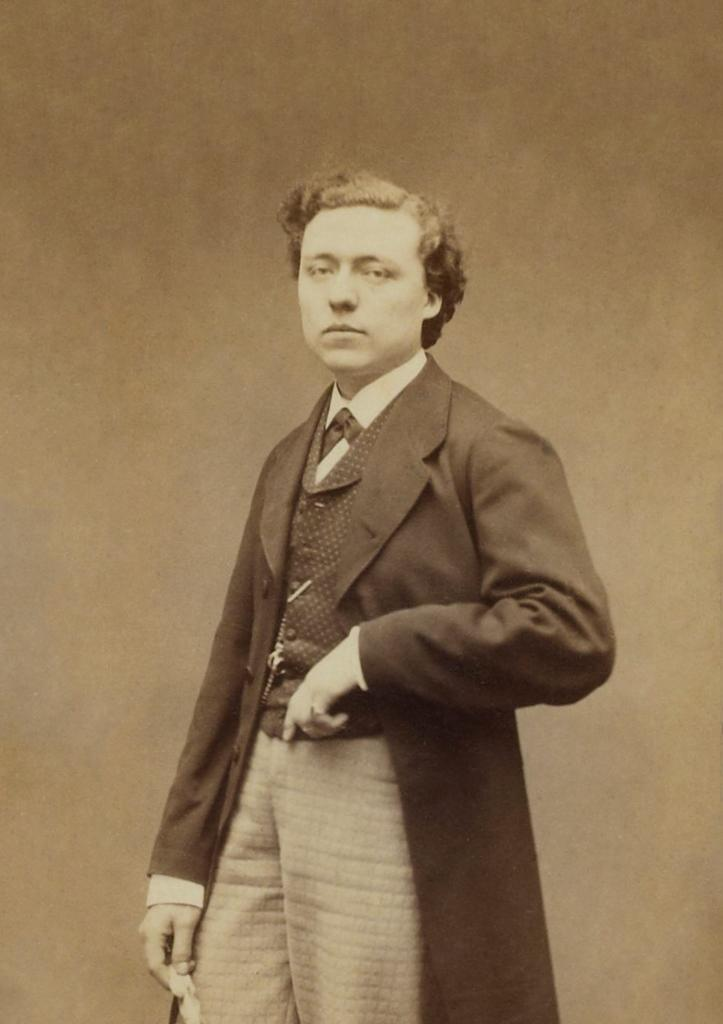What is the main subject of the image? There is a person standing in the front of the image. Can you describe the person's attire? The person is wearing a suit. What is the color scheme of the image? The image is in black and white. What type of copper quarter can be seen in the person's hand in the image? There is no copper quarter present in the image. Is the person engaged in a fight in the image? There is no indication of a fight in the image; the person is simply standing. 